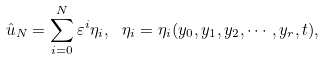<formula> <loc_0><loc_0><loc_500><loc_500>\hat { u } _ { N } = \sum _ { i = 0 } ^ { N } \varepsilon ^ { i } \eta _ { i } , \ \eta _ { i } = \eta _ { i } ( y _ { 0 } , y _ { 1 } , y _ { 2 } , \cdots , y _ { r } , t ) ,</formula> 